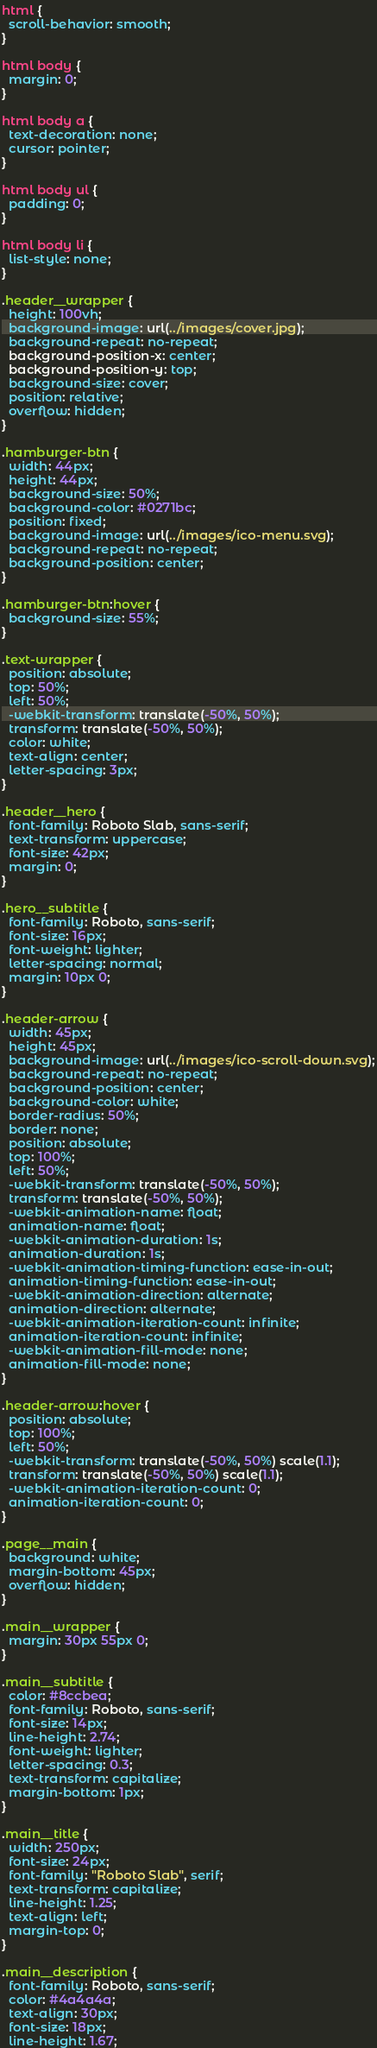Convert code to text. <code><loc_0><loc_0><loc_500><loc_500><_CSS_>html {
  scroll-behavior: smooth;
}

html body {
  margin: 0;
}

html body a {
  text-decoration: none;
  cursor: pointer;
}

html body ul {
  padding: 0;
}

html body li {
  list-style: none;
}

.header__wrapper {
  height: 100vh;
  background-image: url(../images/cover.jpg);
  background-repeat: no-repeat;
  background-position-x: center;
  background-position-y: top;
  background-size: cover;
  position: relative;
  overflow: hidden;
}

.hamburger-btn {
  width: 44px;
  height: 44px;
  background-size: 50%;
  background-color: #0271bc;
  position: fixed;
  background-image: url(../images/ico-menu.svg);
  background-repeat: no-repeat;
  background-position: center;
}

.hamburger-btn:hover {
  background-size: 55%;
}

.text-wrapper {
  position: absolute;
  top: 50%;
  left: 50%;
  -webkit-transform: translate(-50%, 50%);
  transform: translate(-50%, 50%);
  color: white;
  text-align: center;
  letter-spacing: 3px;
}

.header__hero {
  font-family: Roboto Slab, sans-serif;
  text-transform: uppercase;
  font-size: 42px;
  margin: 0;
}

.hero__subtitle {
  font-family: Roboto, sans-serif;
  font-size: 16px;
  font-weight: lighter;
  letter-spacing: normal;
  margin: 10px 0;
}

.header-arrow {
  width: 45px;
  height: 45px;
  background-image: url(../images/ico-scroll-down.svg);
  background-repeat: no-repeat;
  background-position: center;
  background-color: white;
  border-radius: 50%;
  border: none;
  position: absolute;
  top: 100%;
  left: 50%;
  -webkit-transform: translate(-50%, 50%);
  transform: translate(-50%, 50%);
  -webkit-animation-name: float;
  animation-name: float;
  -webkit-animation-duration: 1s;
  animation-duration: 1s;
  -webkit-animation-timing-function: ease-in-out;
  animation-timing-function: ease-in-out;
  -webkit-animation-direction: alternate;
  animation-direction: alternate;
  -webkit-animation-iteration-count: infinite;
  animation-iteration-count: infinite;
  -webkit-animation-fill-mode: none;
  animation-fill-mode: none;
}

.header-arrow:hover {
  position: absolute;
  top: 100%;
  left: 50%;
  -webkit-transform: translate(-50%, 50%) scale(1.1);
  transform: translate(-50%, 50%) scale(1.1);
  -webkit-animation-iteration-count: 0;
  animation-iteration-count: 0;
}

.page__main {
  background: white;
  margin-bottom: 45px;
  overflow: hidden;
}

.main__wrapper {
  margin: 30px 55px 0;
}

.main__subtitle {
  color: #8ccbea;
  font-family: Roboto, sans-serif;
  font-size: 14px;
  line-height: 2.74;
  font-weight: lighter;
  letter-spacing: 0.3;
  text-transform: capitalize;
  margin-bottom: 1px;
}

.main__title {
  width: 250px;
  font-size: 24px;
  font-family: "Roboto Slab", serif;
  text-transform: capitalize;
  line-height: 1.25;
  text-align: left;
  margin-top: 0;
}

.main__description {
  font-family: Roboto, sans-serif;
  color: #4a4a4a;
  text-align: 30px;
  font-size: 18px;
  line-height: 1.67;</code> 